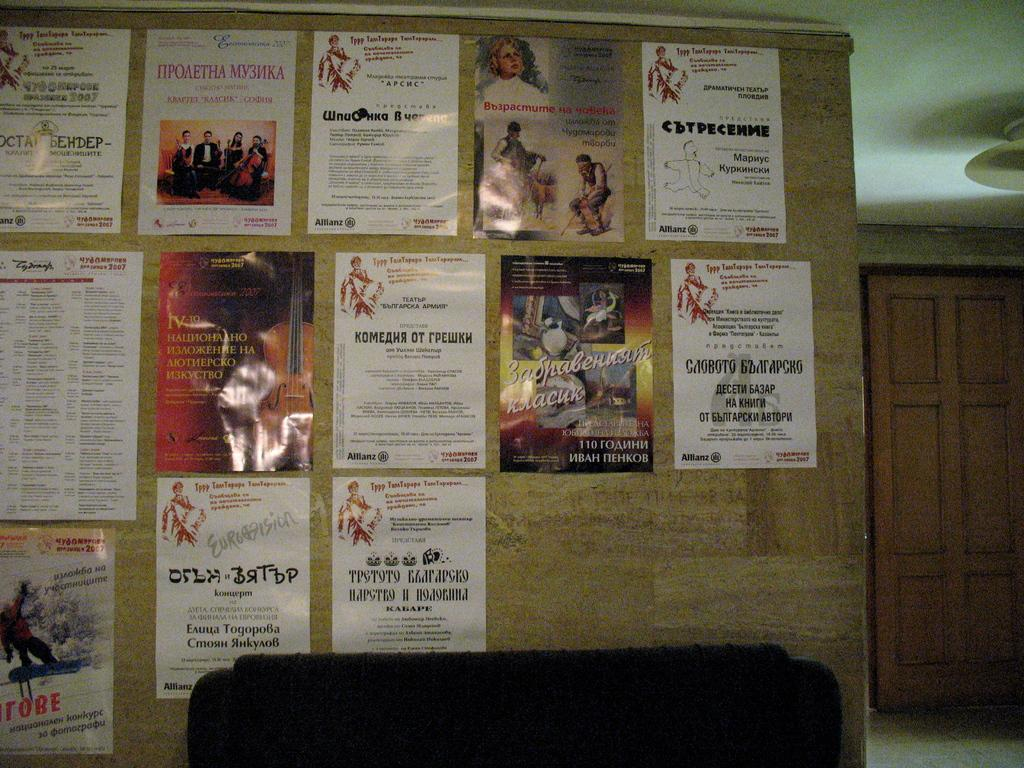<image>
Offer a succinct explanation of the picture presented. Several posters are on a bulliten board, including one that is dated 2007. 